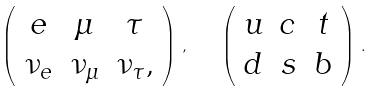Convert formula to latex. <formula><loc_0><loc_0><loc_500><loc_500>\left ( \begin{array} { c c c } e & \mu & \tau \\ \nu _ { e } & \nu _ { \mu } & \nu _ { \tau } , \end{array} \right ) \, , \quad \left ( \begin{array} { c c c } u & c & t \\ d & s & b \end{array} \right ) \, .</formula> 